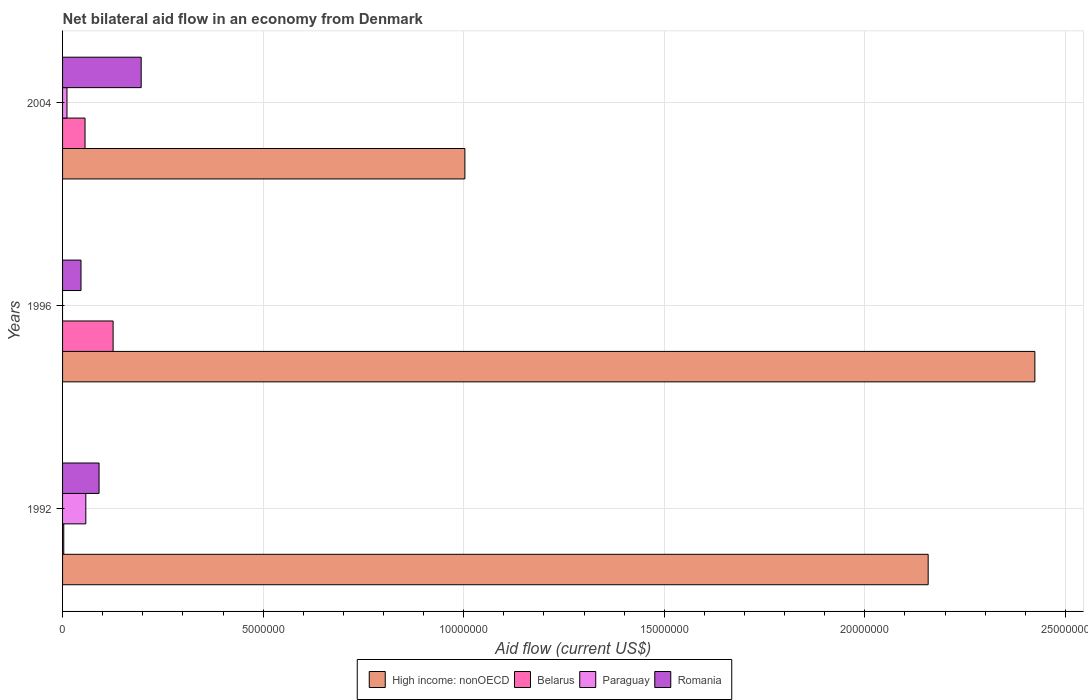How many different coloured bars are there?
Your response must be concise. 4. Are the number of bars per tick equal to the number of legend labels?
Keep it short and to the point. No. Are the number of bars on each tick of the Y-axis equal?
Provide a short and direct response. No. How many bars are there on the 2nd tick from the top?
Your answer should be very brief. 3. What is the net bilateral aid flow in High income: nonOECD in 1996?
Your answer should be compact. 2.42e+07. Across all years, what is the maximum net bilateral aid flow in Romania?
Provide a short and direct response. 1.96e+06. Across all years, what is the minimum net bilateral aid flow in Romania?
Provide a short and direct response. 4.60e+05. What is the total net bilateral aid flow in High income: nonOECD in the graph?
Ensure brevity in your answer.  5.58e+07. What is the difference between the net bilateral aid flow in Paraguay in 1992 and that in 2004?
Offer a very short reply. 4.70e+05. What is the difference between the net bilateral aid flow in Paraguay in 1992 and the net bilateral aid flow in High income: nonOECD in 1996?
Provide a succinct answer. -2.37e+07. What is the average net bilateral aid flow in High income: nonOECD per year?
Your answer should be very brief. 1.86e+07. In the year 1996, what is the difference between the net bilateral aid flow in High income: nonOECD and net bilateral aid flow in Belarus?
Ensure brevity in your answer.  2.30e+07. In how many years, is the net bilateral aid flow in Belarus greater than 14000000 US$?
Make the answer very short. 0. What is the ratio of the net bilateral aid flow in Belarus in 1992 to that in 2004?
Your answer should be compact. 0.05. Is the difference between the net bilateral aid flow in High income: nonOECD in 1996 and 2004 greater than the difference between the net bilateral aid flow in Belarus in 1996 and 2004?
Make the answer very short. Yes. What is the difference between the highest and the second highest net bilateral aid flow in Belarus?
Provide a succinct answer. 7.00e+05. What is the difference between the highest and the lowest net bilateral aid flow in Belarus?
Offer a very short reply. 1.23e+06. In how many years, is the net bilateral aid flow in High income: nonOECD greater than the average net bilateral aid flow in High income: nonOECD taken over all years?
Offer a very short reply. 2. Is the sum of the net bilateral aid flow in Romania in 1996 and 2004 greater than the maximum net bilateral aid flow in Belarus across all years?
Your response must be concise. Yes. Is it the case that in every year, the sum of the net bilateral aid flow in Belarus and net bilateral aid flow in High income: nonOECD is greater than the sum of net bilateral aid flow in Romania and net bilateral aid flow in Paraguay?
Keep it short and to the point. Yes. How many bars are there?
Make the answer very short. 11. How many years are there in the graph?
Your response must be concise. 3. Does the graph contain grids?
Ensure brevity in your answer.  Yes. Where does the legend appear in the graph?
Offer a terse response. Bottom center. How many legend labels are there?
Provide a succinct answer. 4. What is the title of the graph?
Offer a very short reply. Net bilateral aid flow in an economy from Denmark. Does "Equatorial Guinea" appear as one of the legend labels in the graph?
Provide a succinct answer. No. What is the Aid flow (current US$) in High income: nonOECD in 1992?
Offer a very short reply. 2.16e+07. What is the Aid flow (current US$) in Paraguay in 1992?
Keep it short and to the point. 5.80e+05. What is the Aid flow (current US$) of Romania in 1992?
Offer a very short reply. 9.10e+05. What is the Aid flow (current US$) in High income: nonOECD in 1996?
Provide a succinct answer. 2.42e+07. What is the Aid flow (current US$) of Belarus in 1996?
Provide a short and direct response. 1.26e+06. What is the Aid flow (current US$) of Romania in 1996?
Make the answer very short. 4.60e+05. What is the Aid flow (current US$) of High income: nonOECD in 2004?
Give a very brief answer. 1.00e+07. What is the Aid flow (current US$) of Belarus in 2004?
Your answer should be very brief. 5.60e+05. What is the Aid flow (current US$) in Paraguay in 2004?
Offer a very short reply. 1.10e+05. What is the Aid flow (current US$) in Romania in 2004?
Offer a terse response. 1.96e+06. Across all years, what is the maximum Aid flow (current US$) in High income: nonOECD?
Your answer should be very brief. 2.42e+07. Across all years, what is the maximum Aid flow (current US$) of Belarus?
Offer a terse response. 1.26e+06. Across all years, what is the maximum Aid flow (current US$) of Paraguay?
Ensure brevity in your answer.  5.80e+05. Across all years, what is the maximum Aid flow (current US$) of Romania?
Make the answer very short. 1.96e+06. Across all years, what is the minimum Aid flow (current US$) in High income: nonOECD?
Offer a terse response. 1.00e+07. Across all years, what is the minimum Aid flow (current US$) in Romania?
Your response must be concise. 4.60e+05. What is the total Aid flow (current US$) in High income: nonOECD in the graph?
Offer a terse response. 5.58e+07. What is the total Aid flow (current US$) in Belarus in the graph?
Provide a succinct answer. 1.85e+06. What is the total Aid flow (current US$) in Paraguay in the graph?
Your answer should be very brief. 6.90e+05. What is the total Aid flow (current US$) in Romania in the graph?
Keep it short and to the point. 3.33e+06. What is the difference between the Aid flow (current US$) in High income: nonOECD in 1992 and that in 1996?
Provide a succinct answer. -2.66e+06. What is the difference between the Aid flow (current US$) in Belarus in 1992 and that in 1996?
Your answer should be very brief. -1.23e+06. What is the difference between the Aid flow (current US$) in Romania in 1992 and that in 1996?
Provide a succinct answer. 4.50e+05. What is the difference between the Aid flow (current US$) in High income: nonOECD in 1992 and that in 2004?
Your response must be concise. 1.16e+07. What is the difference between the Aid flow (current US$) of Belarus in 1992 and that in 2004?
Your response must be concise. -5.30e+05. What is the difference between the Aid flow (current US$) in Paraguay in 1992 and that in 2004?
Offer a very short reply. 4.70e+05. What is the difference between the Aid flow (current US$) in Romania in 1992 and that in 2004?
Ensure brevity in your answer.  -1.05e+06. What is the difference between the Aid flow (current US$) in High income: nonOECD in 1996 and that in 2004?
Offer a very short reply. 1.42e+07. What is the difference between the Aid flow (current US$) in Belarus in 1996 and that in 2004?
Keep it short and to the point. 7.00e+05. What is the difference between the Aid flow (current US$) in Romania in 1996 and that in 2004?
Your answer should be very brief. -1.50e+06. What is the difference between the Aid flow (current US$) in High income: nonOECD in 1992 and the Aid flow (current US$) in Belarus in 1996?
Offer a very short reply. 2.03e+07. What is the difference between the Aid flow (current US$) of High income: nonOECD in 1992 and the Aid flow (current US$) of Romania in 1996?
Make the answer very short. 2.11e+07. What is the difference between the Aid flow (current US$) in Belarus in 1992 and the Aid flow (current US$) in Romania in 1996?
Ensure brevity in your answer.  -4.30e+05. What is the difference between the Aid flow (current US$) of Paraguay in 1992 and the Aid flow (current US$) of Romania in 1996?
Your answer should be compact. 1.20e+05. What is the difference between the Aid flow (current US$) of High income: nonOECD in 1992 and the Aid flow (current US$) of Belarus in 2004?
Provide a succinct answer. 2.10e+07. What is the difference between the Aid flow (current US$) of High income: nonOECD in 1992 and the Aid flow (current US$) of Paraguay in 2004?
Give a very brief answer. 2.15e+07. What is the difference between the Aid flow (current US$) of High income: nonOECD in 1992 and the Aid flow (current US$) of Romania in 2004?
Your answer should be very brief. 1.96e+07. What is the difference between the Aid flow (current US$) of Belarus in 1992 and the Aid flow (current US$) of Paraguay in 2004?
Ensure brevity in your answer.  -8.00e+04. What is the difference between the Aid flow (current US$) in Belarus in 1992 and the Aid flow (current US$) in Romania in 2004?
Offer a very short reply. -1.93e+06. What is the difference between the Aid flow (current US$) in Paraguay in 1992 and the Aid flow (current US$) in Romania in 2004?
Provide a short and direct response. -1.38e+06. What is the difference between the Aid flow (current US$) of High income: nonOECD in 1996 and the Aid flow (current US$) of Belarus in 2004?
Your answer should be very brief. 2.37e+07. What is the difference between the Aid flow (current US$) in High income: nonOECD in 1996 and the Aid flow (current US$) in Paraguay in 2004?
Keep it short and to the point. 2.41e+07. What is the difference between the Aid flow (current US$) in High income: nonOECD in 1996 and the Aid flow (current US$) in Romania in 2004?
Provide a short and direct response. 2.23e+07. What is the difference between the Aid flow (current US$) in Belarus in 1996 and the Aid flow (current US$) in Paraguay in 2004?
Give a very brief answer. 1.15e+06. What is the difference between the Aid flow (current US$) of Belarus in 1996 and the Aid flow (current US$) of Romania in 2004?
Ensure brevity in your answer.  -7.00e+05. What is the average Aid flow (current US$) of High income: nonOECD per year?
Offer a very short reply. 1.86e+07. What is the average Aid flow (current US$) of Belarus per year?
Offer a terse response. 6.17e+05. What is the average Aid flow (current US$) of Paraguay per year?
Make the answer very short. 2.30e+05. What is the average Aid flow (current US$) of Romania per year?
Offer a terse response. 1.11e+06. In the year 1992, what is the difference between the Aid flow (current US$) in High income: nonOECD and Aid flow (current US$) in Belarus?
Provide a succinct answer. 2.16e+07. In the year 1992, what is the difference between the Aid flow (current US$) of High income: nonOECD and Aid flow (current US$) of Paraguay?
Make the answer very short. 2.10e+07. In the year 1992, what is the difference between the Aid flow (current US$) of High income: nonOECD and Aid flow (current US$) of Romania?
Give a very brief answer. 2.07e+07. In the year 1992, what is the difference between the Aid flow (current US$) in Belarus and Aid flow (current US$) in Paraguay?
Provide a succinct answer. -5.50e+05. In the year 1992, what is the difference between the Aid flow (current US$) in Belarus and Aid flow (current US$) in Romania?
Make the answer very short. -8.80e+05. In the year 1992, what is the difference between the Aid flow (current US$) in Paraguay and Aid flow (current US$) in Romania?
Give a very brief answer. -3.30e+05. In the year 1996, what is the difference between the Aid flow (current US$) in High income: nonOECD and Aid flow (current US$) in Belarus?
Your answer should be very brief. 2.30e+07. In the year 1996, what is the difference between the Aid flow (current US$) in High income: nonOECD and Aid flow (current US$) in Romania?
Your answer should be compact. 2.38e+07. In the year 2004, what is the difference between the Aid flow (current US$) of High income: nonOECD and Aid flow (current US$) of Belarus?
Ensure brevity in your answer.  9.47e+06. In the year 2004, what is the difference between the Aid flow (current US$) of High income: nonOECD and Aid flow (current US$) of Paraguay?
Offer a terse response. 9.92e+06. In the year 2004, what is the difference between the Aid flow (current US$) of High income: nonOECD and Aid flow (current US$) of Romania?
Ensure brevity in your answer.  8.07e+06. In the year 2004, what is the difference between the Aid flow (current US$) of Belarus and Aid flow (current US$) of Paraguay?
Keep it short and to the point. 4.50e+05. In the year 2004, what is the difference between the Aid flow (current US$) of Belarus and Aid flow (current US$) of Romania?
Your response must be concise. -1.40e+06. In the year 2004, what is the difference between the Aid flow (current US$) of Paraguay and Aid flow (current US$) of Romania?
Give a very brief answer. -1.85e+06. What is the ratio of the Aid flow (current US$) in High income: nonOECD in 1992 to that in 1996?
Ensure brevity in your answer.  0.89. What is the ratio of the Aid flow (current US$) of Belarus in 1992 to that in 1996?
Provide a short and direct response. 0.02. What is the ratio of the Aid flow (current US$) of Romania in 1992 to that in 1996?
Keep it short and to the point. 1.98. What is the ratio of the Aid flow (current US$) in High income: nonOECD in 1992 to that in 2004?
Provide a succinct answer. 2.15. What is the ratio of the Aid flow (current US$) of Belarus in 1992 to that in 2004?
Your response must be concise. 0.05. What is the ratio of the Aid flow (current US$) in Paraguay in 1992 to that in 2004?
Provide a short and direct response. 5.27. What is the ratio of the Aid flow (current US$) of Romania in 1992 to that in 2004?
Provide a short and direct response. 0.46. What is the ratio of the Aid flow (current US$) in High income: nonOECD in 1996 to that in 2004?
Your answer should be compact. 2.42. What is the ratio of the Aid flow (current US$) in Belarus in 1996 to that in 2004?
Ensure brevity in your answer.  2.25. What is the ratio of the Aid flow (current US$) in Romania in 1996 to that in 2004?
Give a very brief answer. 0.23. What is the difference between the highest and the second highest Aid flow (current US$) of High income: nonOECD?
Give a very brief answer. 2.66e+06. What is the difference between the highest and the second highest Aid flow (current US$) of Belarus?
Your answer should be very brief. 7.00e+05. What is the difference between the highest and the second highest Aid flow (current US$) in Romania?
Give a very brief answer. 1.05e+06. What is the difference between the highest and the lowest Aid flow (current US$) of High income: nonOECD?
Make the answer very short. 1.42e+07. What is the difference between the highest and the lowest Aid flow (current US$) of Belarus?
Your answer should be compact. 1.23e+06. What is the difference between the highest and the lowest Aid flow (current US$) of Paraguay?
Your response must be concise. 5.80e+05. What is the difference between the highest and the lowest Aid flow (current US$) in Romania?
Your answer should be compact. 1.50e+06. 